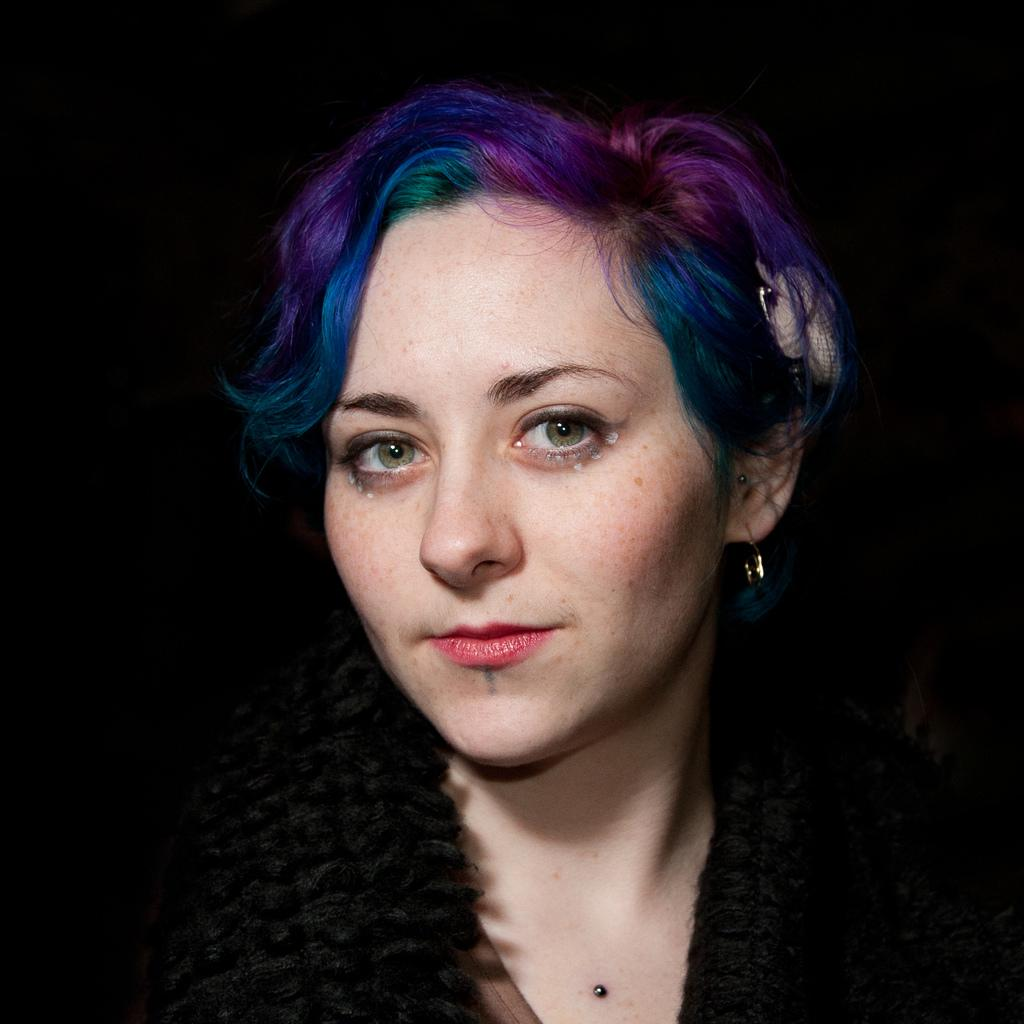Who is the main subject in the image? There is a woman in the center of the image. What is a noticeable feature of the woman's appearance? The woman has colored hair. What color is the background of the image? The background of the image is black. How many mice are helping the woman in the image? There are no mice present in the image, and therefore no assistance from mice can be observed. 